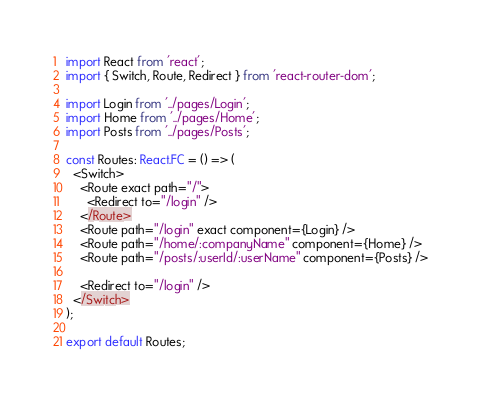Convert code to text. <code><loc_0><loc_0><loc_500><loc_500><_TypeScript_>import React from 'react';
import { Switch, Route, Redirect } from 'react-router-dom';

import Login from '../pages/Login';
import Home from '../pages/Home';
import Posts from '../pages/Posts';

const Routes: React.FC = () => (
  <Switch>
    <Route exact path="/">
      <Redirect to="/login" />
    </Route>
    <Route path="/login" exact component={Login} />
    <Route path="/home/:companyName" component={Home} />
    <Route path="/posts/:userId/:userName" component={Posts} />

    <Redirect to="/login" />
  </Switch>
);

export default Routes;
</code> 